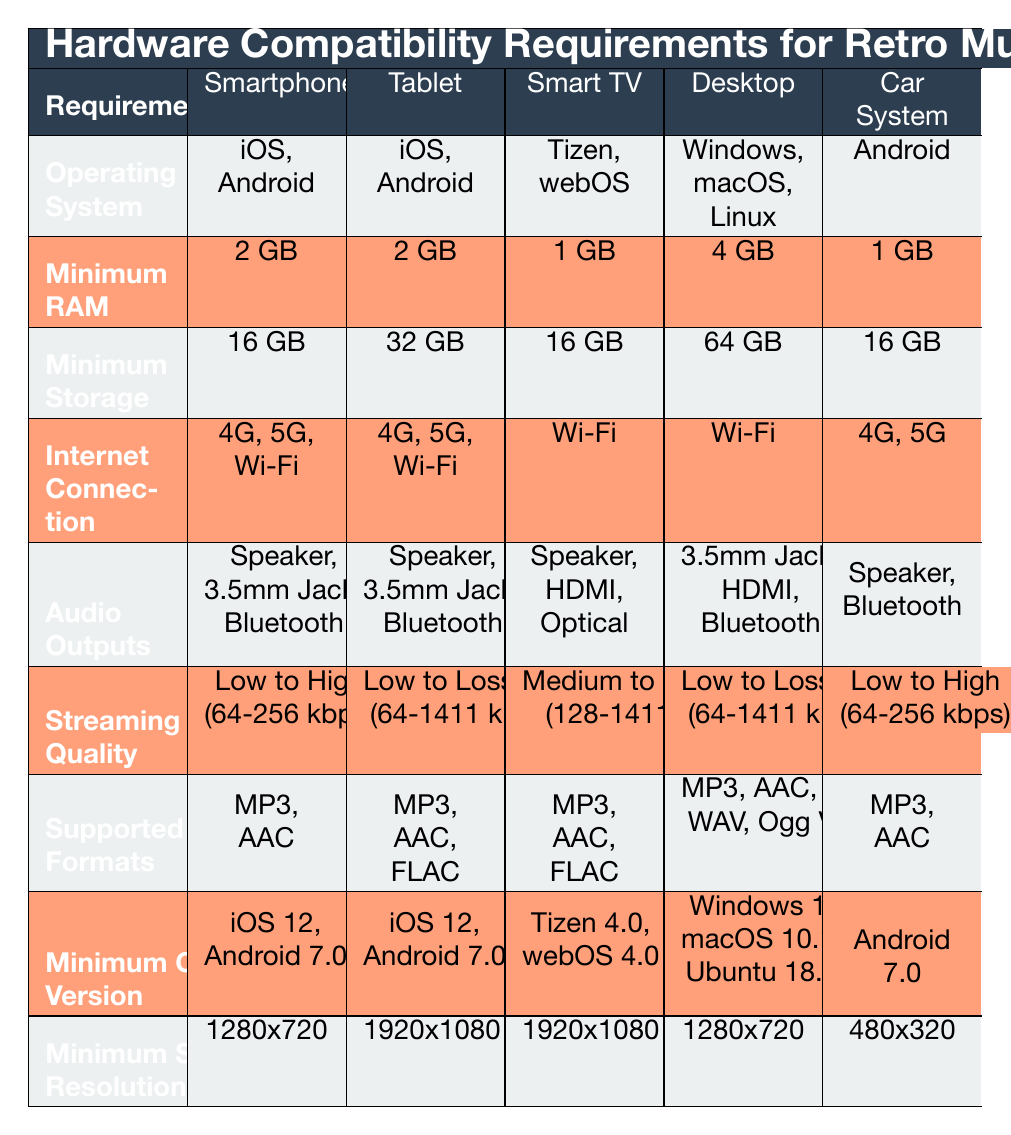What operating systems are supported on a Smart TV? The Smart TV supports Tizen and webOS, as listed in the "Operating System" row under the Smart TV column.
Answer: Tizen, webOS What is the minimum RAM requirement for using the app on a smartphone? The table specifies that the minimum RAM for a smartphone is 2 GB under the "Minimum RAM" row in the smartphone column.
Answer: 2 GB Can a Car Infotainment System stream audio at Lossless quality? The table shows that the maximum streaming quality specified for a Car Infotainment System is Low to High (64-256 kbps), which does not include Lossless quality.
Answer: No What are the audio output options available for a Desktop Computer? The Desktop Computer options for audio output, shown in the "Audio Outputs" row, include 3.5mm Jack, HDMI, and Bluetooth.
Answer: 3.5mm Jack, HDMI, Bluetooth What is the minimum OS version required for tablets? The "Minimum OS Version" row indicates that tablets require either iOS 12 or Android 7.0.
Answer: iOS 12, Android 7.0 How many audio outputs are available for a Tablet? The Tablet has three audio output options: Built-in Speaker, 3.5mm Headphone Jack, and Bluetooth, as listed in the "Audio Outputs" row.
Answer: Three Which device type has the highest minimum storage requirement? Comparing the "Minimum Storage" values in the table, the Desktop Computer has the highest requirement of 64 GB.
Answer: Desktop Computer What is the average minimum screen resolution required for all devices? The minimum screen resolutions are: Smartphone (1280x720), Tablet (1920x1080), Smart TV (1920x1080), Desktop (1280x720), Car System (480x320). The average is calculated as follows: (1280+1920+1920+1280+480) / 5 = 1308.
Answer: 1308 Are there any devices that require a minimum of 8 GB RAM? The table shows 4 GB as the maximum minimum RAM requirement across all device types, hence no devices require 8 GB.
Answer: No 